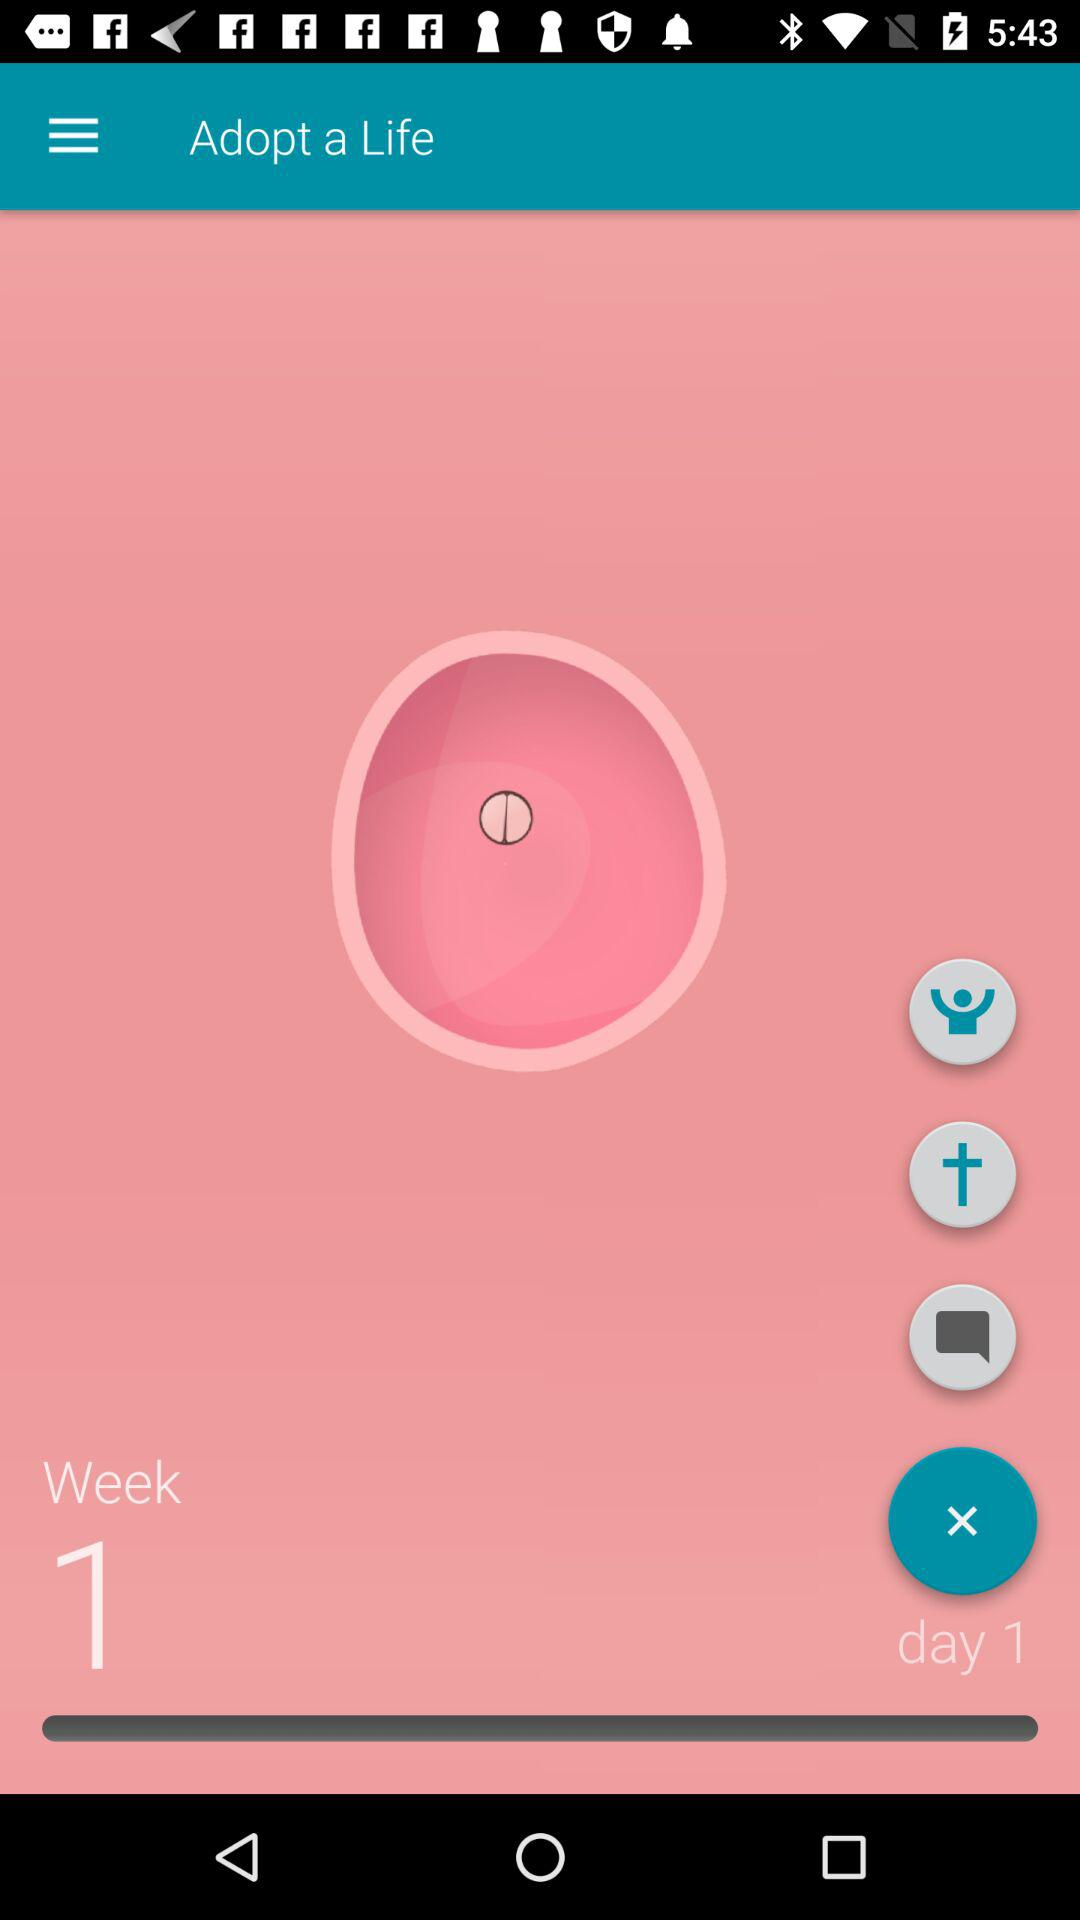What week is it? It is week 1. 